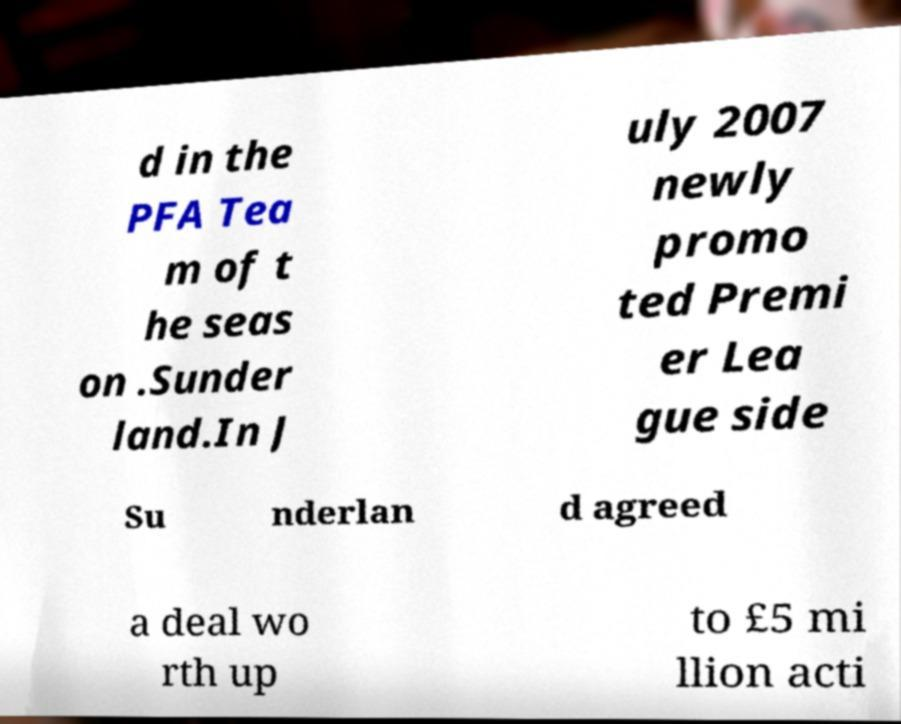Can you accurately transcribe the text from the provided image for me? d in the PFA Tea m of t he seas on .Sunder land.In J uly 2007 newly promo ted Premi er Lea gue side Su nderlan d agreed a deal wo rth up to £5 mi llion acti 